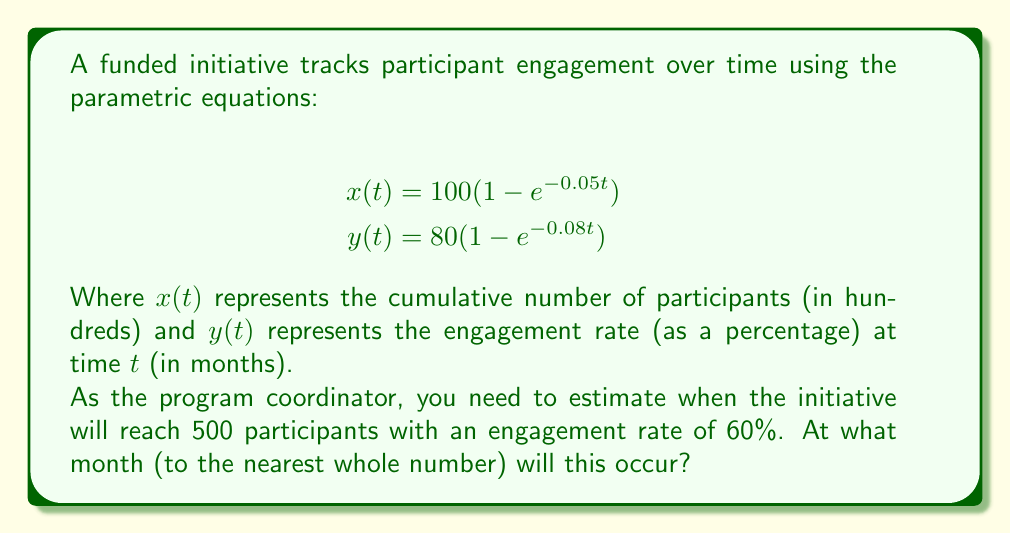Can you solve this math problem? To solve this problem, we need to find the time $t$ when both conditions are met simultaneously:

1. $x(t) = 5$ (500 participants = 5 hundred)
2. $y(t) = 60$ (60% engagement rate)

Let's solve each equation separately:

For $x(t) = 5$:
$$5 = 100(1 - e^{-0.05t})$$
$$0.95 = e^{-0.05t}$$
$$\ln(0.95) = -0.05t$$
$$t = -\frac{\ln(0.95)}{0.05} \approx 1.0256$$

For $y(t) = 60$:
$$60 = 80(1 - e^{-0.08t})$$
$$0.75 = 1 - e^{-0.08t}$$
$$0.25 = e^{-0.08t}$$
$$\ln(0.25) = -0.08t$$
$$t = -\frac{\ln(0.25)}{0.08} \approx 17.3286$$

The larger of these two values is approximately 17.3286 months, which represents the time when both conditions will be met. Rounding to the nearest whole number gives us 17 months.
Answer: 17 months 